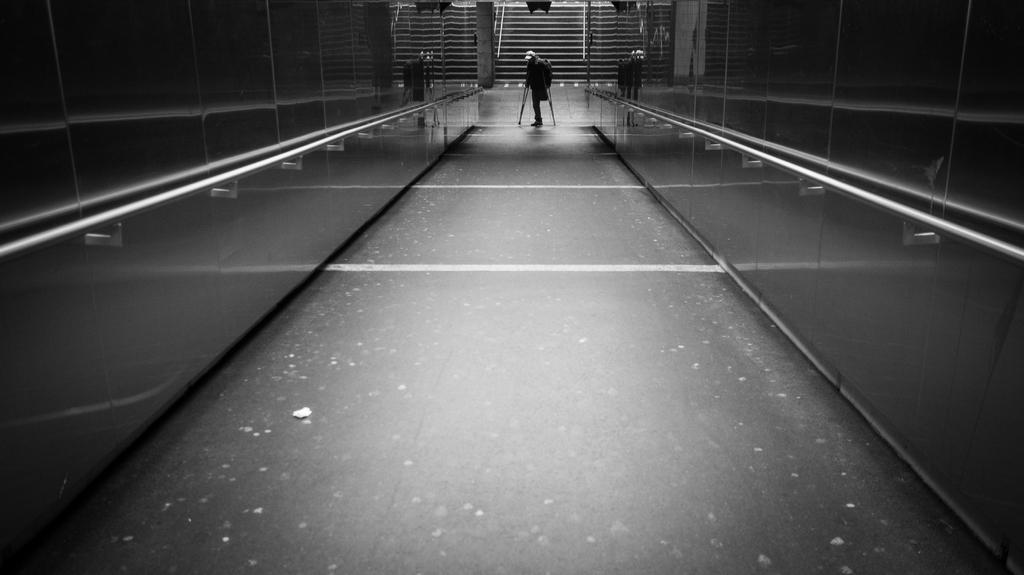What is the main subject of the image? There is a person in the image. What is the person doing in the image? The person is on the floor and holding crutches. Can you describe the surroundings of the person? There are walls with a metal surface and rods in the image. What can be seen in the background of the image? There are steps visible in the background of the image. What type of button is being used to hold the yam in the image? There is no button or yam present in the image. What type of shoe is the person wearing in the image? The image does not show the person's shoes, so it cannot be determined from the image. 